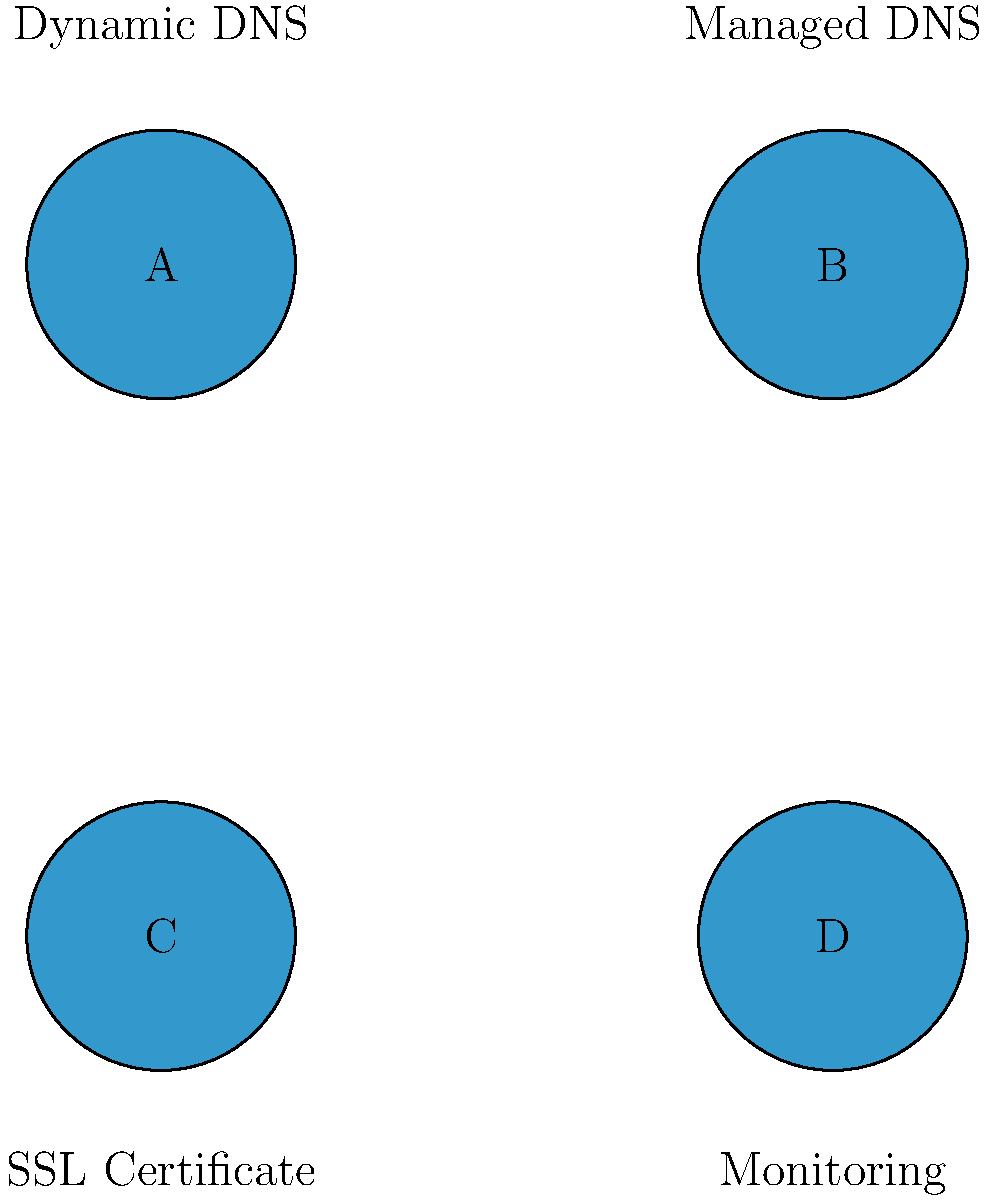Match the No-IP service names to their corresponding icons. Which icon represents the Dynamic DNS service? To answer this question, let's go through the icons and service names step-by-step:

1. We see four icons labeled A, B, C, and D.
2. Each icon has a service name associated with it:
   - Above icon A: Dynamic DNS
   - Above icon B: Managed DNS
   - Below icon C: SSL Certificate
   - Below icon D: Monitoring
3. The question asks specifically about the Dynamic DNS service.
4. Looking at the image, we can see that the Dynamic DNS service is associated with icon A.

Therefore, the icon that represents the Dynamic DNS service is A.
Answer: A 